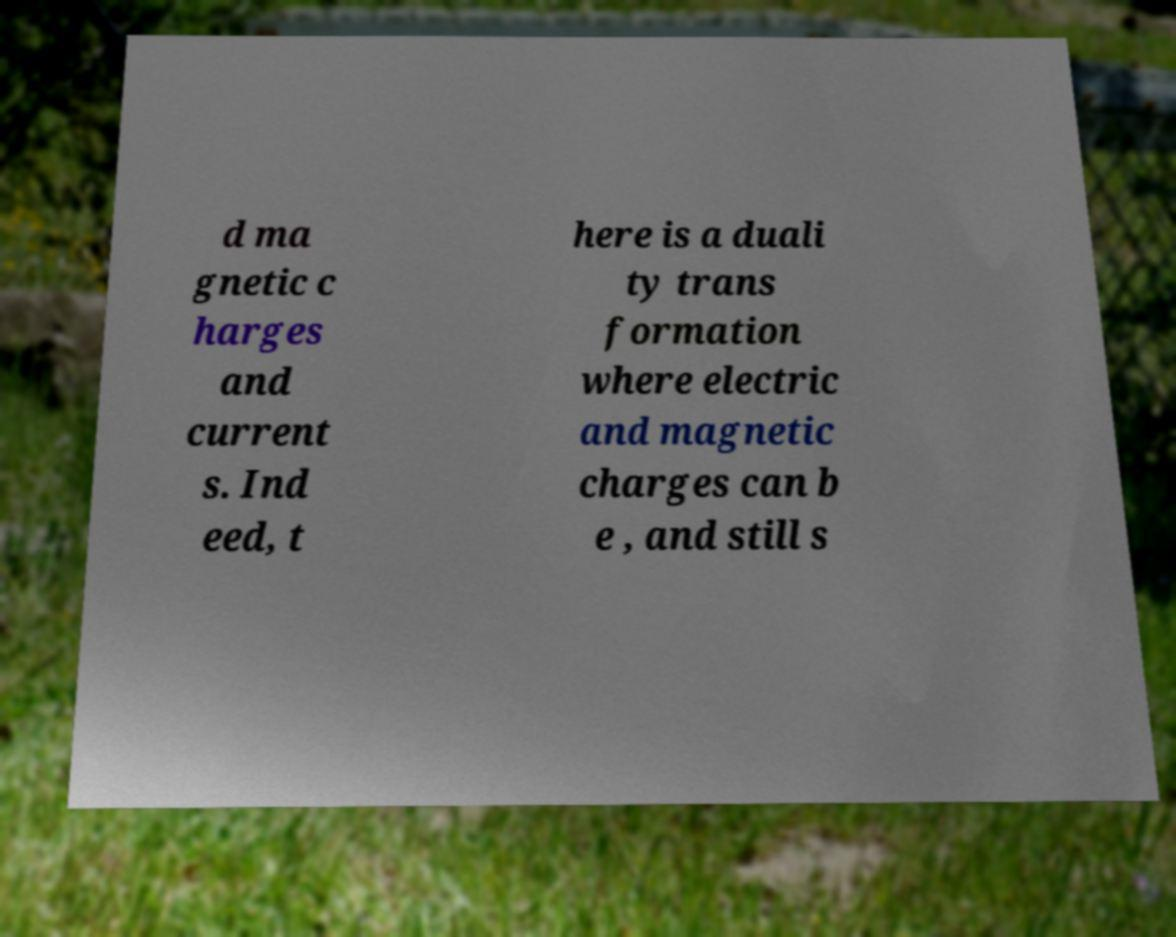Could you extract and type out the text from this image? d ma gnetic c harges and current s. Ind eed, t here is a duali ty trans formation where electric and magnetic charges can b e , and still s 